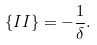<formula> <loc_0><loc_0><loc_500><loc_500>\{ I I \} = - \frac { 1 } { \delta } .</formula> 